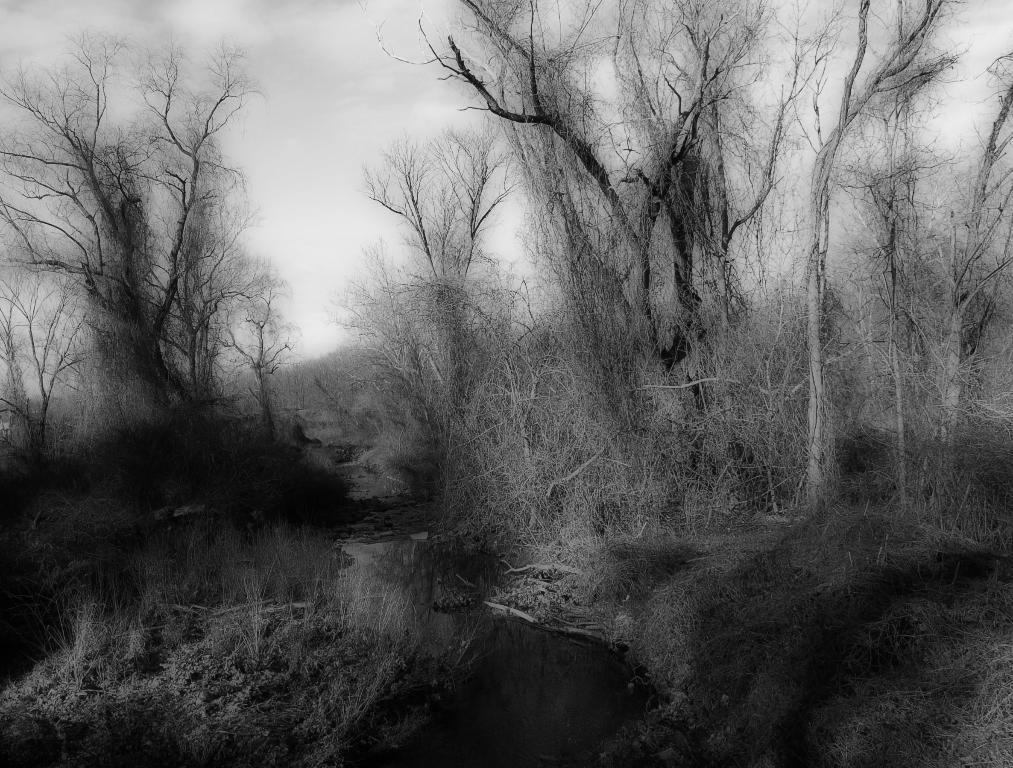What type of vegetation can be seen in the image? There are trees in the image. What type of ground cover is visible in the image? There is grass visible in the image. What natural element can be seen between the trees in the image? There is water visible in the image between the trees. What type of net can be seen hanging from the trees in the image? There is no net present in the image; it only features trees, grass, and water. How many legs can be seen in the image? There are no legs visible in the image, as it only features natural elements like trees, grass, and water. 